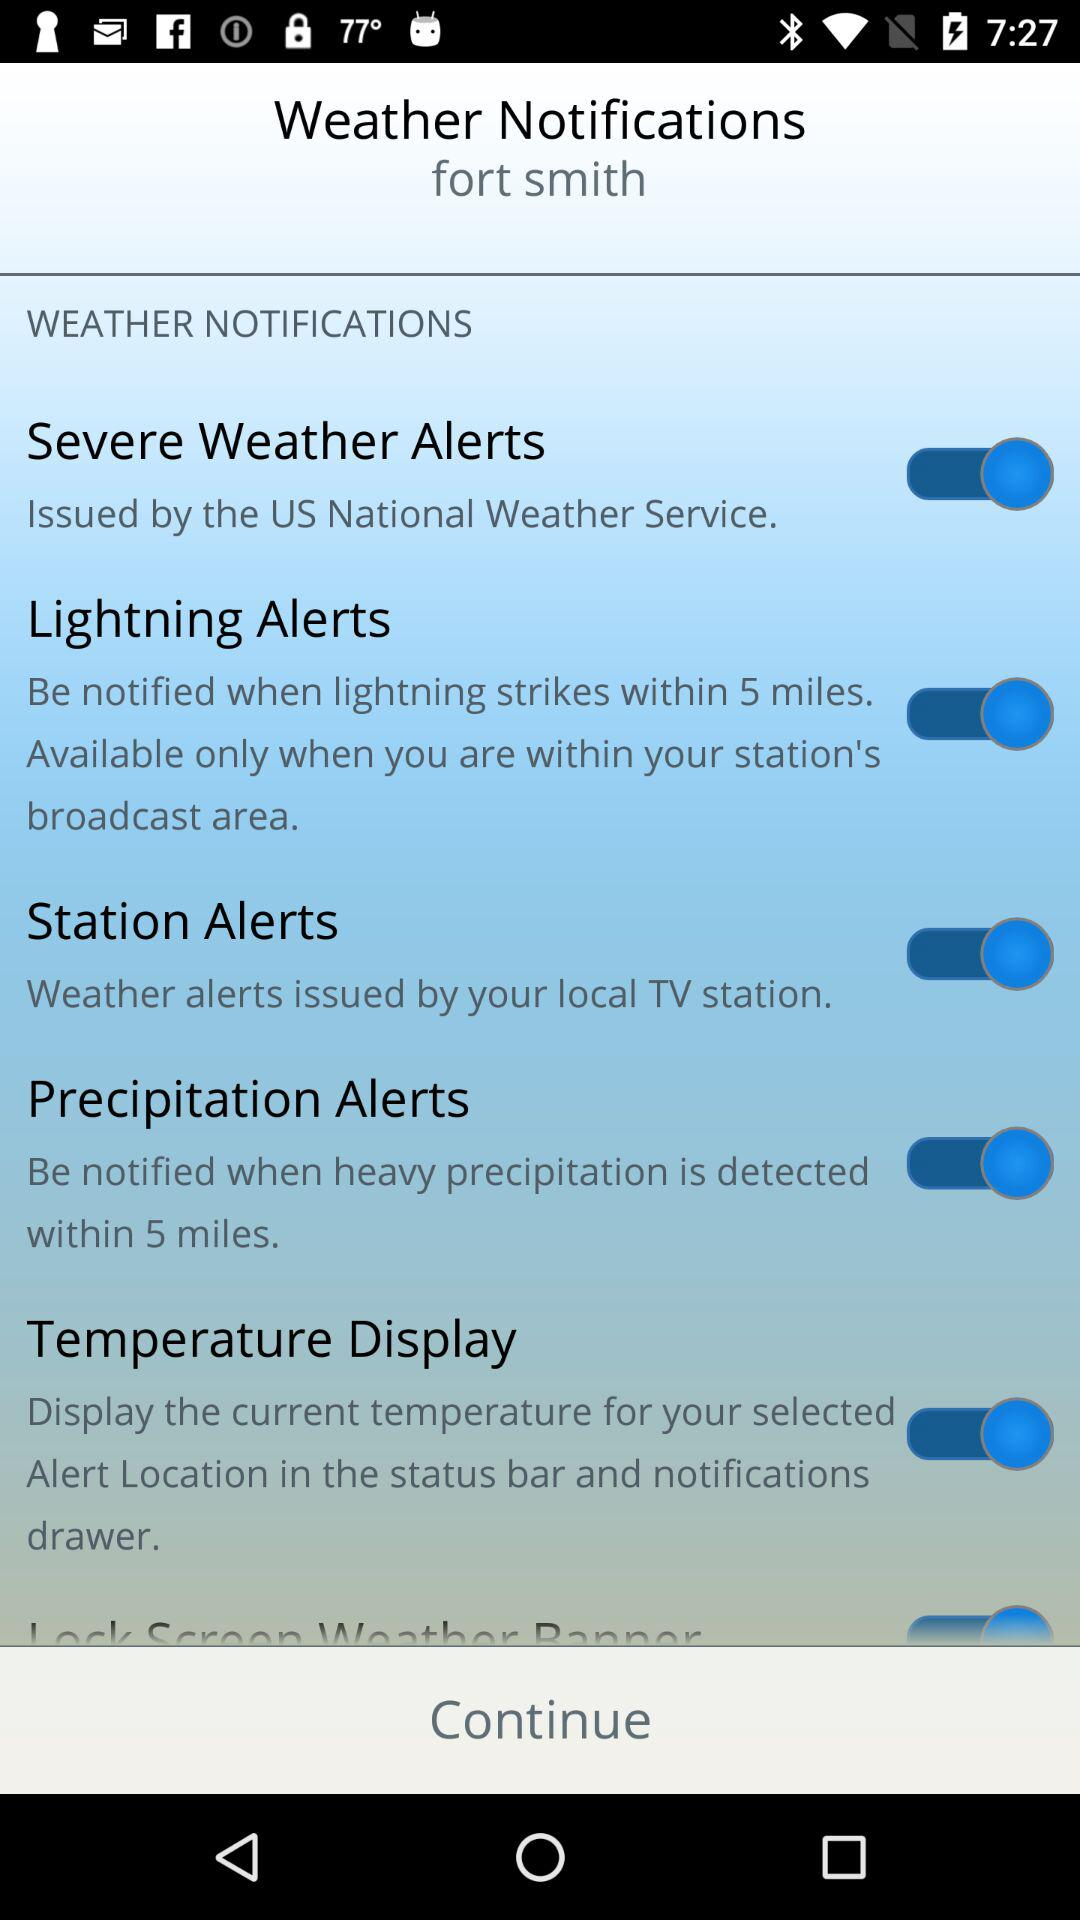What is the status of "Severe Weather Alerts"? The status is on. 